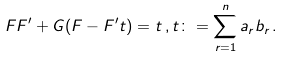Convert formula to latex. <formula><loc_0><loc_0><loc_500><loc_500>F F ^ { \prime } + G ( F - F ^ { \prime } t ) = t \, , t \colon = \sum _ { r = 1 } ^ { n } a _ { r } b _ { r } \, .</formula> 